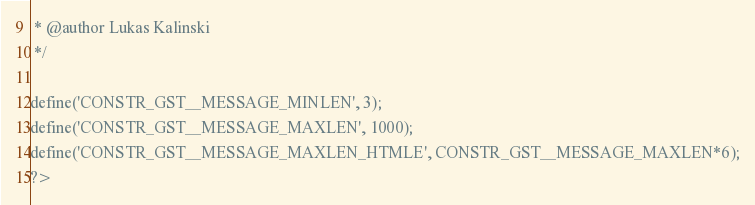<code> <loc_0><loc_0><loc_500><loc_500><_PHP_> * @author Lukas Kalinski
 */

define('CONSTR_GST__MESSAGE_MINLEN', 3);
define('CONSTR_GST__MESSAGE_MAXLEN', 1000);
define('CONSTR_GST__MESSAGE_MAXLEN_HTMLE', CONSTR_GST__MESSAGE_MAXLEN*6);
?></code> 